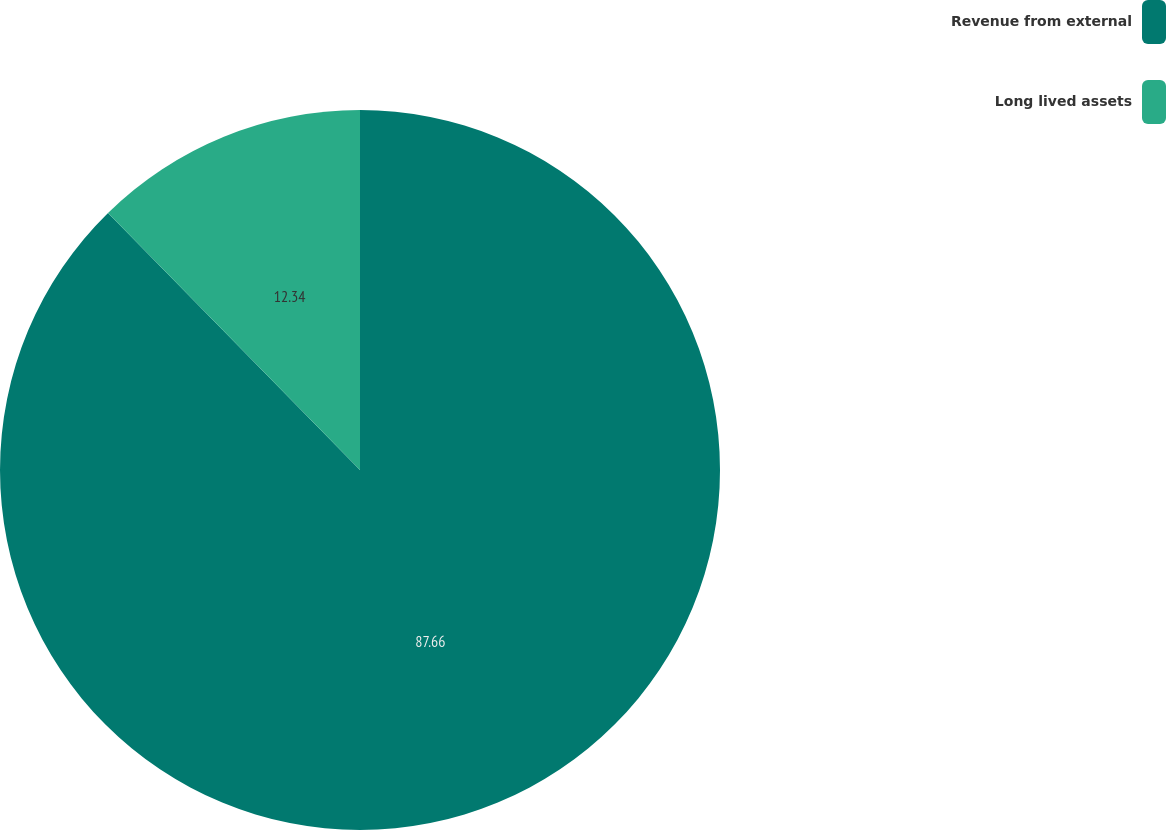Convert chart. <chart><loc_0><loc_0><loc_500><loc_500><pie_chart><fcel>Revenue from external<fcel>Long lived assets<nl><fcel>87.66%<fcel>12.34%<nl></chart> 